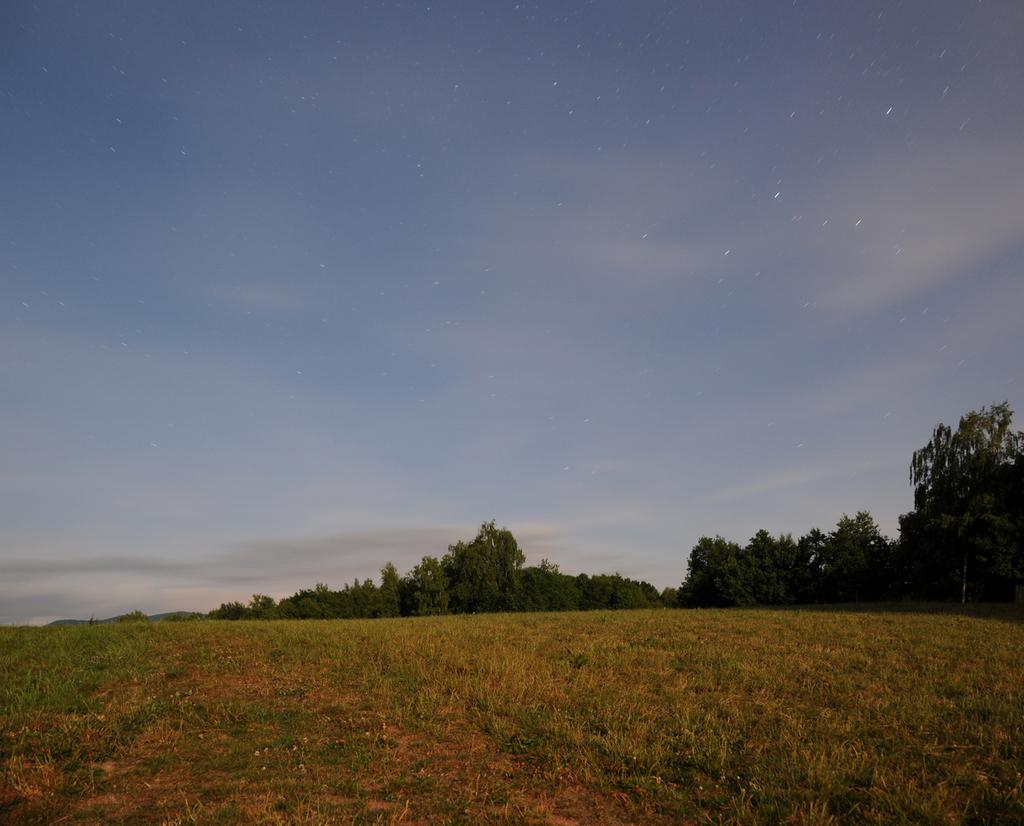What type of vegetation is present in the image? There is grass in the image. What color is the grass? The grass is green. What other natural elements can be seen in the image? There are trees in the image. What color are the trees? The trees are green. What can be seen in the background of the image? The sky is visible in the background of the image. What colors are present in the sky? The sky is blue and white. What type of brass instrument is being played in the image? There is no brass instrument present in the image; it features grass, trees, and a blue and white sky. What invention is being used to water the green trees in the image? There is no invention depicted in the image; it simply shows trees and grass in their natural state. 